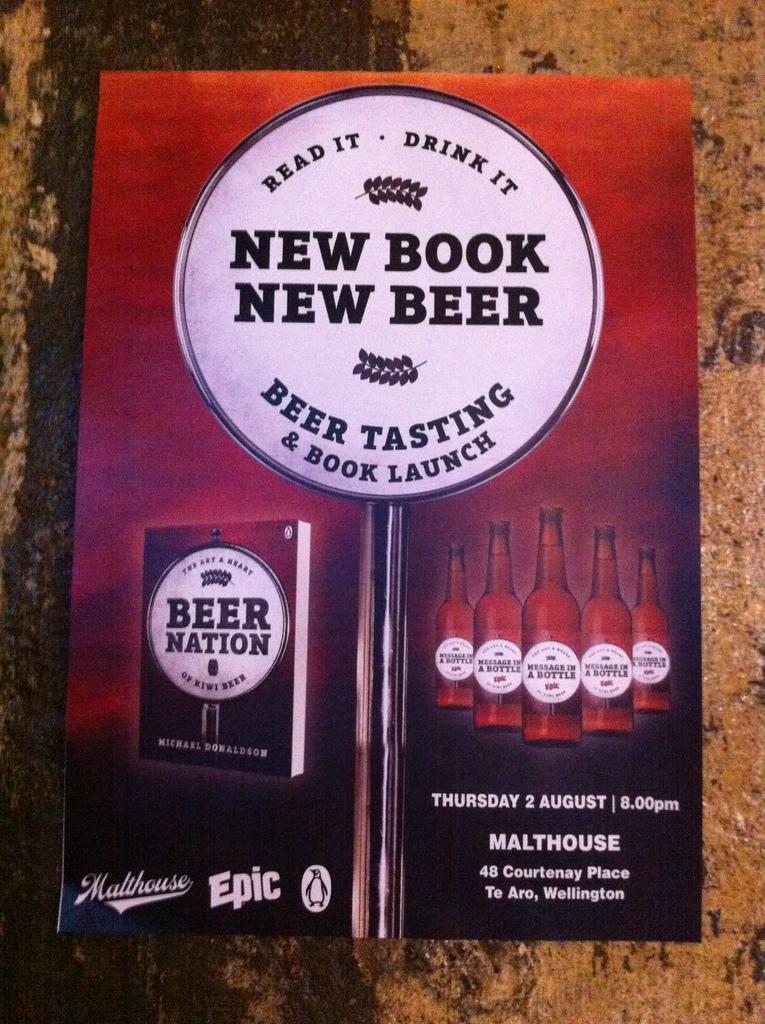What drink is being advertised?
Make the answer very short. Beer. What is the date of the event?
Your answer should be very brief. 2 august. 